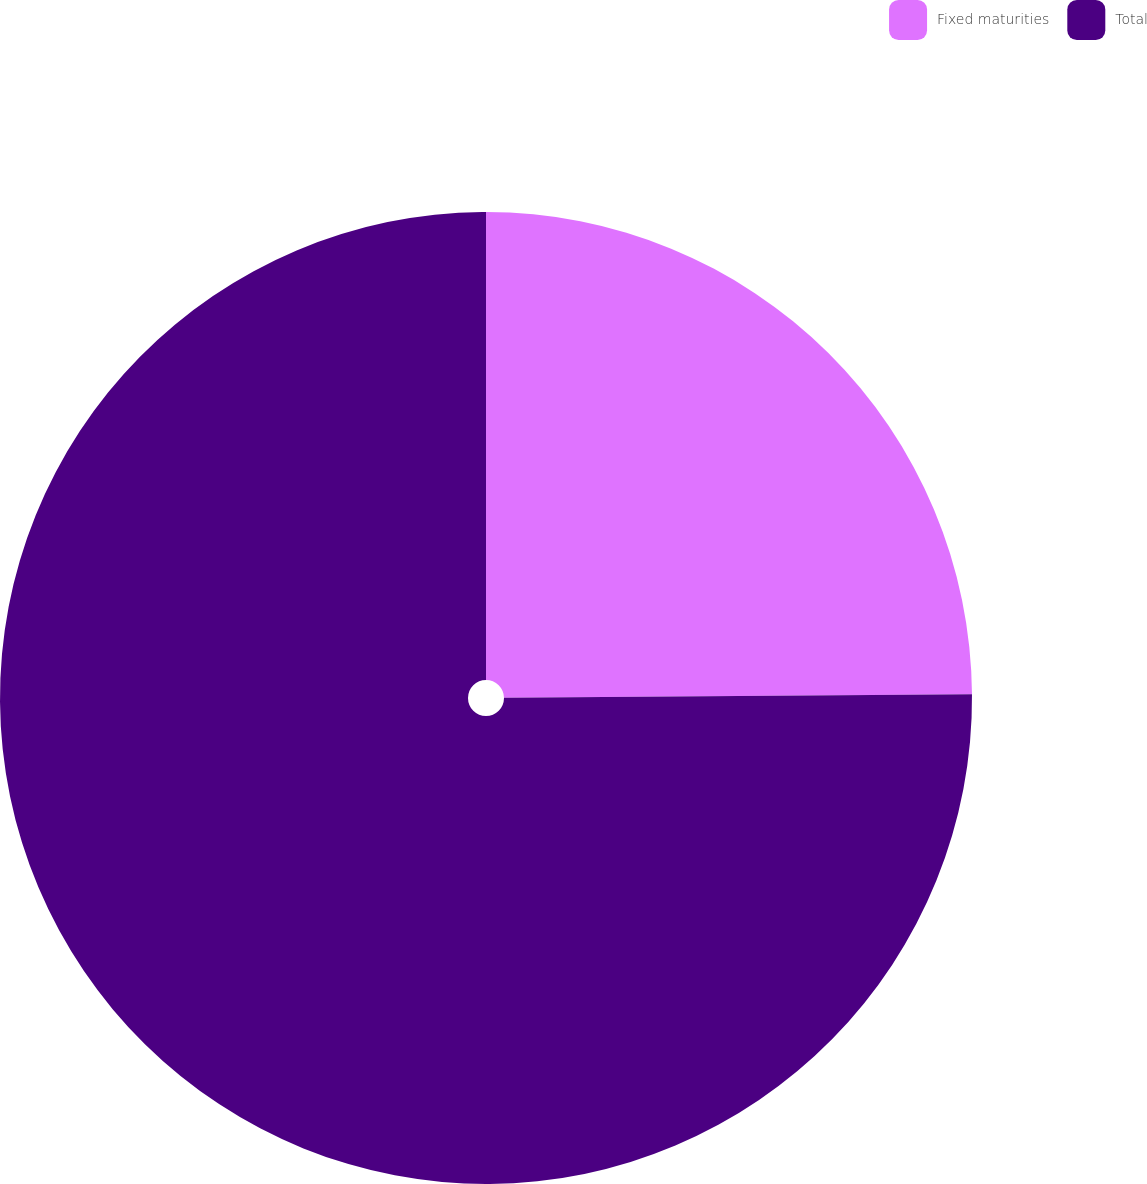<chart> <loc_0><loc_0><loc_500><loc_500><pie_chart><fcel>Fixed maturities<fcel>Total<nl><fcel>24.88%<fcel>75.12%<nl></chart> 